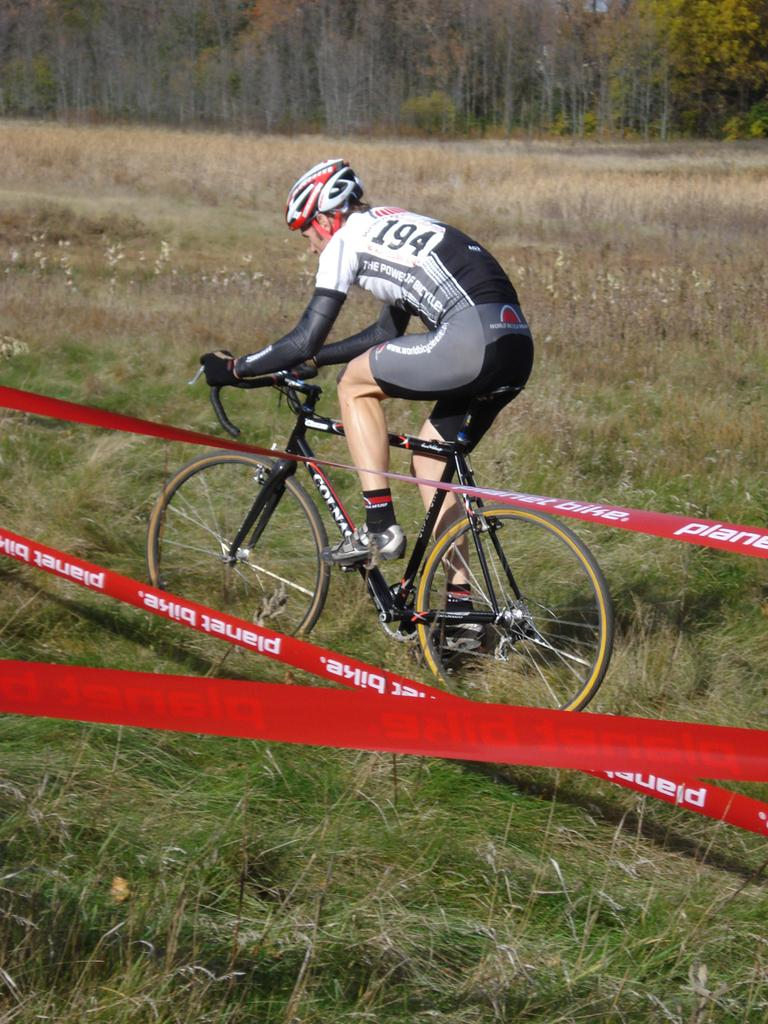What is the main activity being performed by the person in the image? The person is cycling in the image. On what surface is the person cycling? The person is cycling on the grass. What can be seen beside the person while cycling? There are red colored stripes beside the person. What type of natural scenery is visible in the background of the image? There are trees in the background of the image. How many legs does the servant have in the image? There is no servant present in the image, so it is not possible to determine the number of legs they might have. 